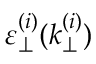<formula> <loc_0><loc_0><loc_500><loc_500>\varepsilon _ { \perp } ^ { ( i ) } ( k _ { \perp } ^ { ( i ) } )</formula> 